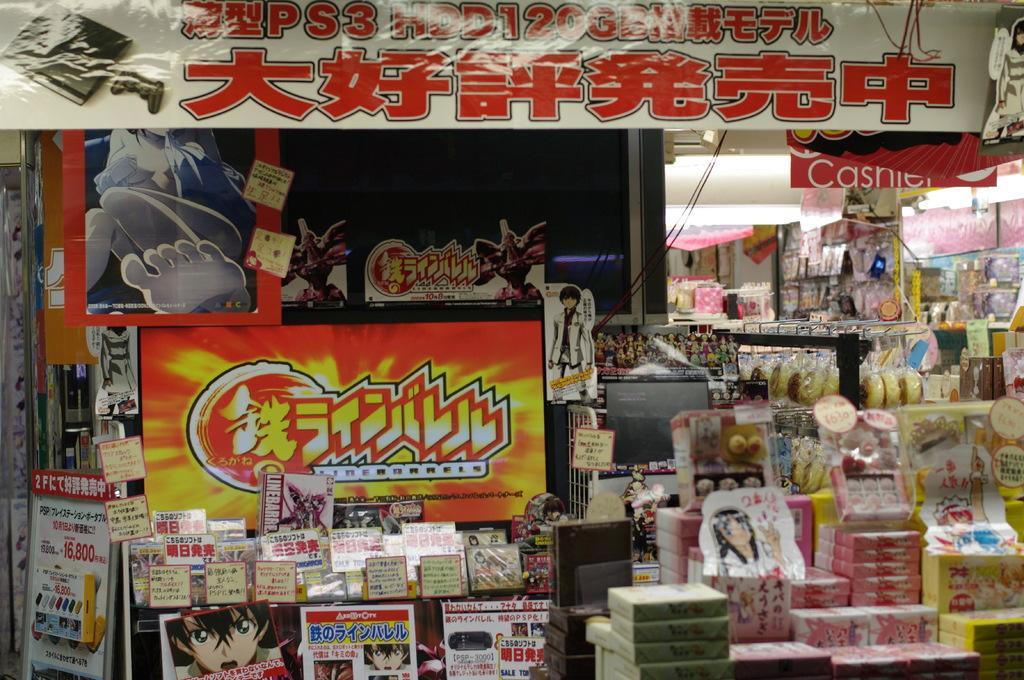How would you summarize this image in a sentence or two? In the image we can see the shop, in the shop we can see there are many items kept. Here we can see the poster and text on it. Here we can see the lights and the cable wires. 